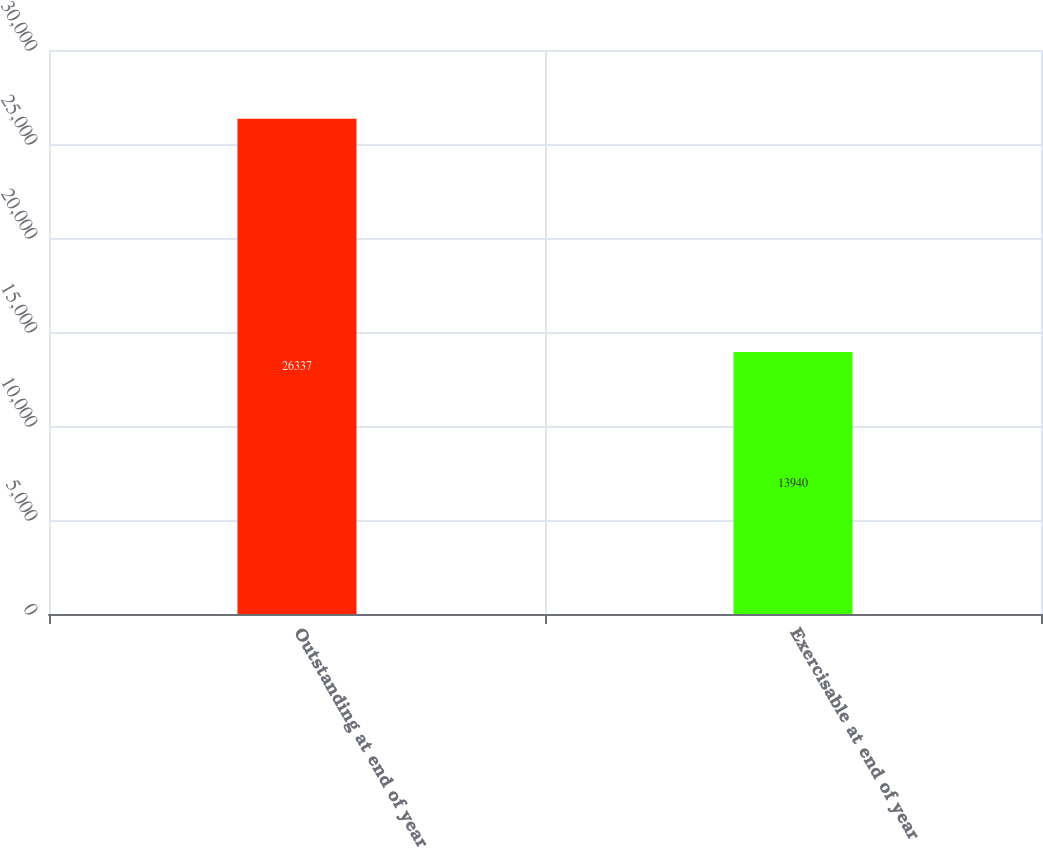Convert chart. <chart><loc_0><loc_0><loc_500><loc_500><bar_chart><fcel>Outstanding at end of year<fcel>Exercisable at end of year<nl><fcel>26337<fcel>13940<nl></chart> 